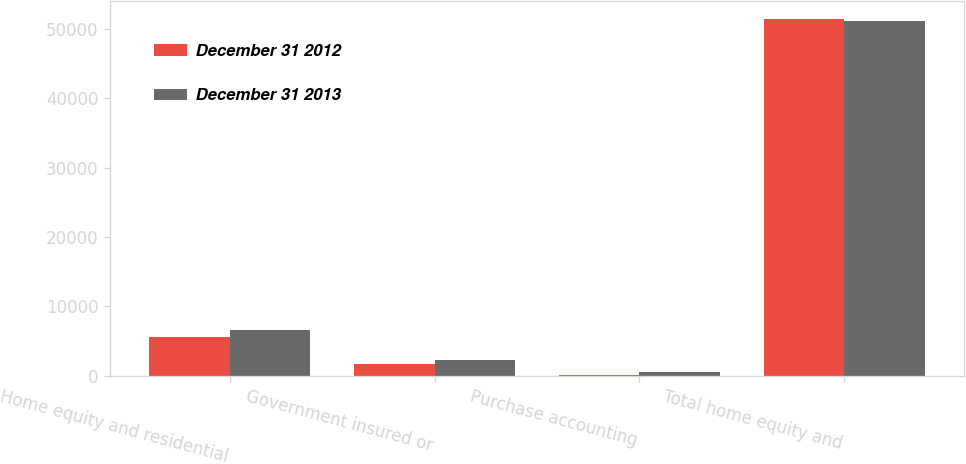Convert chart. <chart><loc_0><loc_0><loc_500><loc_500><stacked_bar_chart><ecel><fcel>Home equity and residential<fcel>Government insured or<fcel>Purchase accounting<fcel>Total home equity and<nl><fcel>December 31 2012<fcel>5548<fcel>1704<fcel>116<fcel>51512<nl><fcel>December 31 2013<fcel>6638<fcel>2279<fcel>482<fcel>51160<nl></chart> 